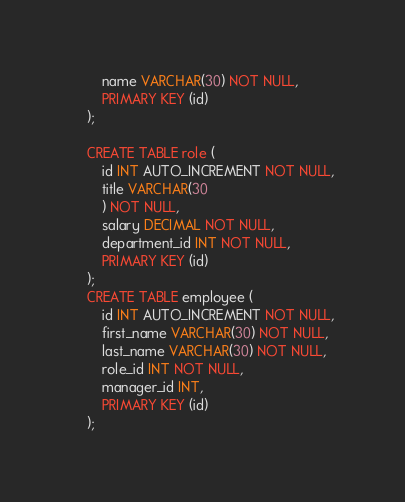<code> <loc_0><loc_0><loc_500><loc_500><_SQL_>        name VARCHAR(30) NOT NULL,
        PRIMARY KEY (id)
    );

    CREATE TABLE role (
        id INT AUTO_INCREMENT NOT NULL,
        title VARCHAR(30
        ) NOT NULL,
        salary DECIMAL NOT NULL,
        department_id INT NOT NULL,
        PRIMARY KEY (id)
    );
    CREATE TABLE employee (
        id INT AUTO_INCREMENT NOT NULL,
        first_name VARCHAR(30) NOT NULL,
        last_name VARCHAR(30) NOT NULL,
        role_id INT NOT NULL,
        manager_id INT,
        PRIMARY KEY (id)
    );

</code> 